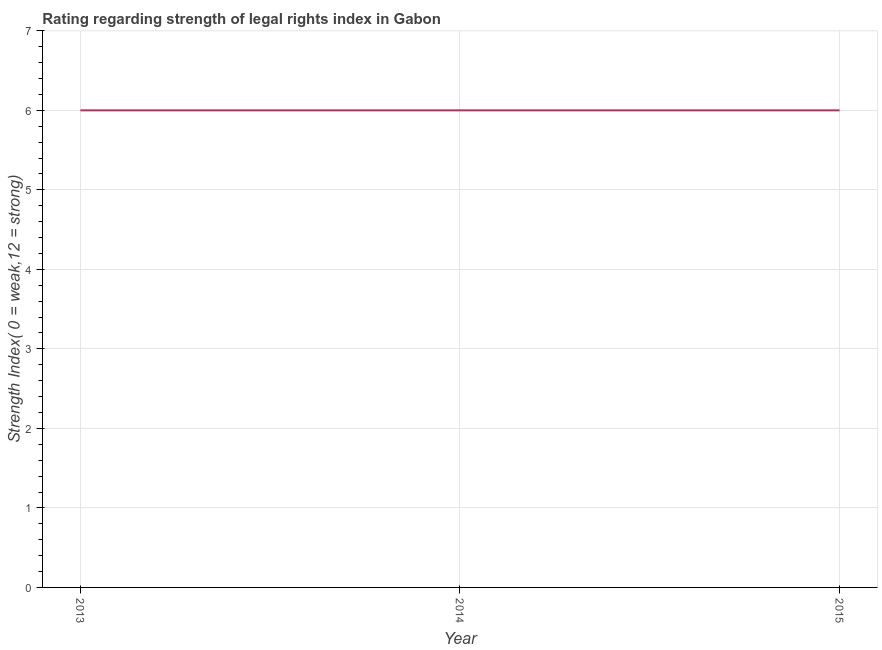Across all years, what is the maximum strength of legal rights index?
Make the answer very short. 6. Across all years, what is the minimum strength of legal rights index?
Your response must be concise. 6. In which year was the strength of legal rights index maximum?
Ensure brevity in your answer.  2013. In which year was the strength of legal rights index minimum?
Offer a terse response. 2013. What is the sum of the strength of legal rights index?
Make the answer very short. 18. What is the difference between the strength of legal rights index in 2013 and 2014?
Offer a very short reply. 0. What is the median strength of legal rights index?
Keep it short and to the point. 6. Do a majority of the years between 2013 and 2015 (inclusive) have strength of legal rights index greater than 4.6 ?
Your answer should be very brief. Yes. What is the ratio of the strength of legal rights index in 2013 to that in 2014?
Ensure brevity in your answer.  1. Is the difference between the strength of legal rights index in 2013 and 2014 greater than the difference between any two years?
Make the answer very short. Yes. Is the sum of the strength of legal rights index in 2013 and 2014 greater than the maximum strength of legal rights index across all years?
Your response must be concise. Yes. In how many years, is the strength of legal rights index greater than the average strength of legal rights index taken over all years?
Keep it short and to the point. 0. How many years are there in the graph?
Provide a succinct answer. 3. Are the values on the major ticks of Y-axis written in scientific E-notation?
Make the answer very short. No. Does the graph contain any zero values?
Provide a succinct answer. No. What is the title of the graph?
Your response must be concise. Rating regarding strength of legal rights index in Gabon. What is the label or title of the Y-axis?
Offer a terse response. Strength Index( 0 = weak,12 = strong). What is the Strength Index( 0 = weak,12 = strong) of 2013?
Make the answer very short. 6. What is the Strength Index( 0 = weak,12 = strong) in 2015?
Offer a very short reply. 6. What is the difference between the Strength Index( 0 = weak,12 = strong) in 2013 and 2014?
Provide a short and direct response. 0. What is the ratio of the Strength Index( 0 = weak,12 = strong) in 2013 to that in 2015?
Provide a short and direct response. 1. What is the ratio of the Strength Index( 0 = weak,12 = strong) in 2014 to that in 2015?
Keep it short and to the point. 1. 